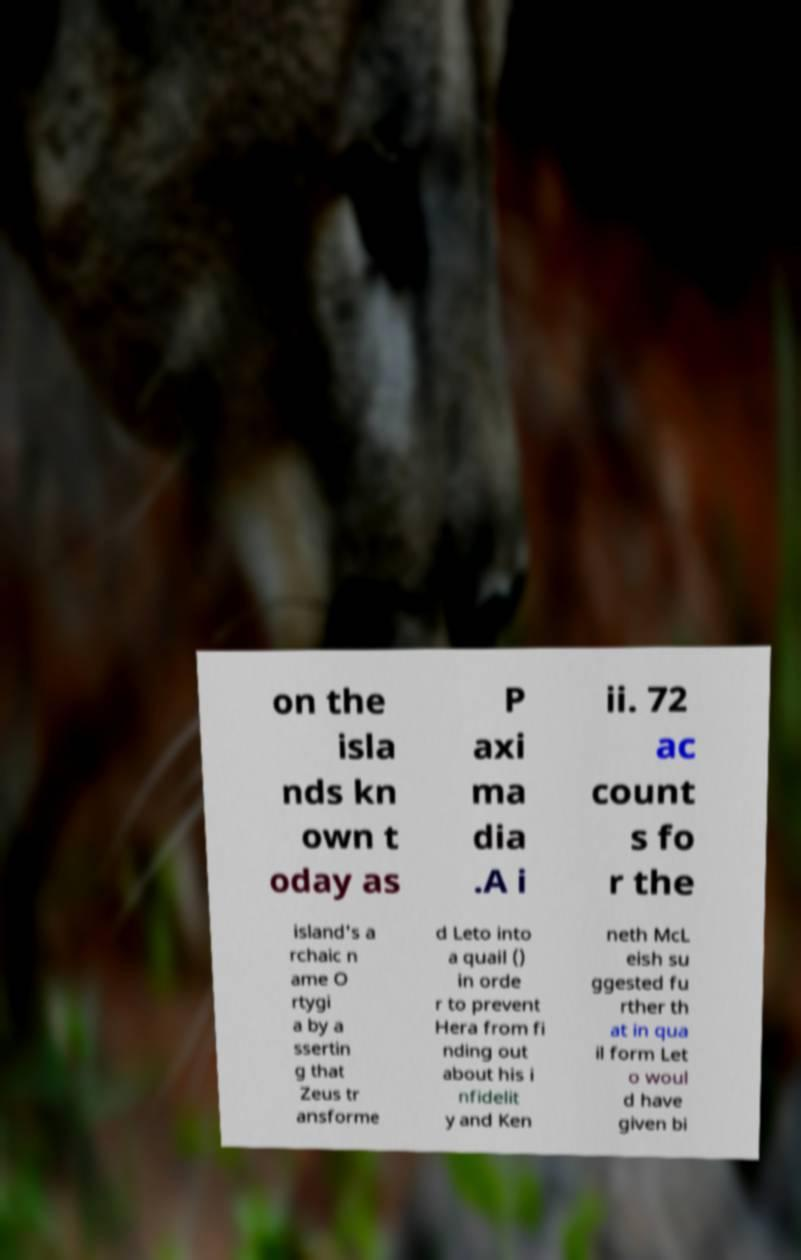Can you accurately transcribe the text from the provided image for me? on the isla nds kn own t oday as P axi ma dia .A i ii. 72 ac count s fo r the island's a rchaic n ame O rtygi a by a ssertin g that Zeus tr ansforme d Leto into a quail () in orde r to prevent Hera from fi nding out about his i nfidelit y and Ken neth McL eish su ggested fu rther th at in qua il form Let o woul d have given bi 